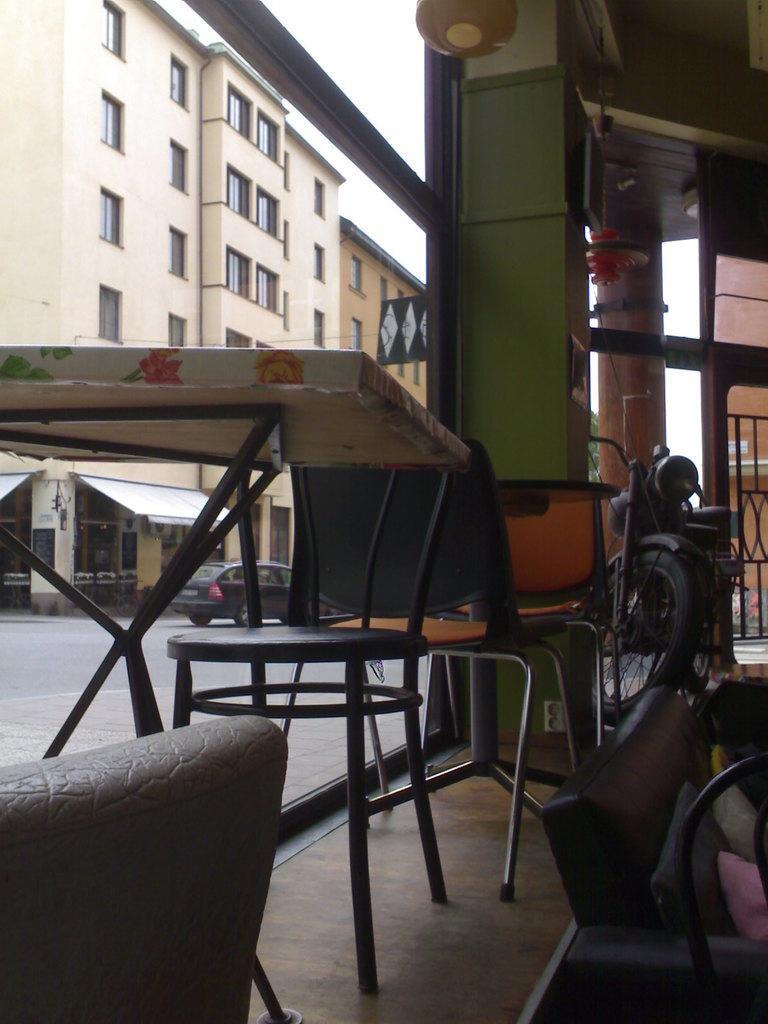Describe this image in one or two sentences. In the image we can see there is a table and chair and on the other side there is a building and another back there is a bike parked. 